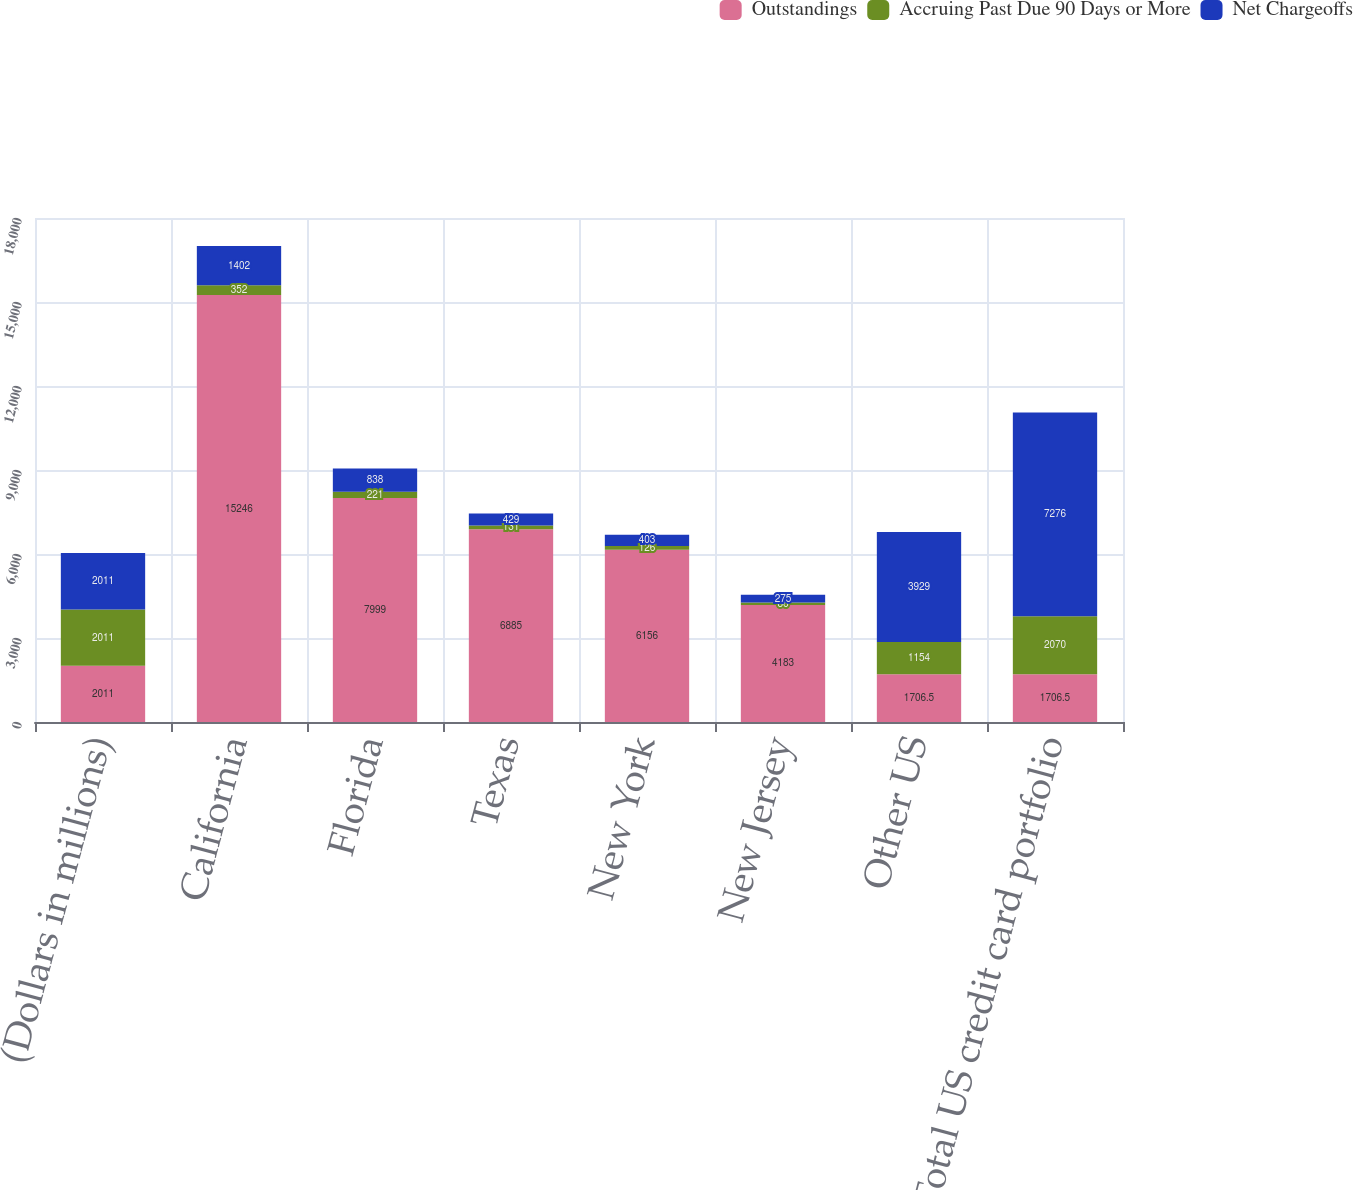Convert chart. <chart><loc_0><loc_0><loc_500><loc_500><stacked_bar_chart><ecel><fcel>(Dollars in millions)<fcel>California<fcel>Florida<fcel>Texas<fcel>New York<fcel>New Jersey<fcel>Other US<fcel>Total US credit card portfolio<nl><fcel>Outstandings<fcel>2011<fcel>15246<fcel>7999<fcel>6885<fcel>6156<fcel>4183<fcel>1706.5<fcel>1706.5<nl><fcel>Accruing Past Due 90 Days or More<fcel>2011<fcel>352<fcel>221<fcel>131<fcel>126<fcel>86<fcel>1154<fcel>2070<nl><fcel>Net Chargeoffs<fcel>2011<fcel>1402<fcel>838<fcel>429<fcel>403<fcel>275<fcel>3929<fcel>7276<nl></chart> 